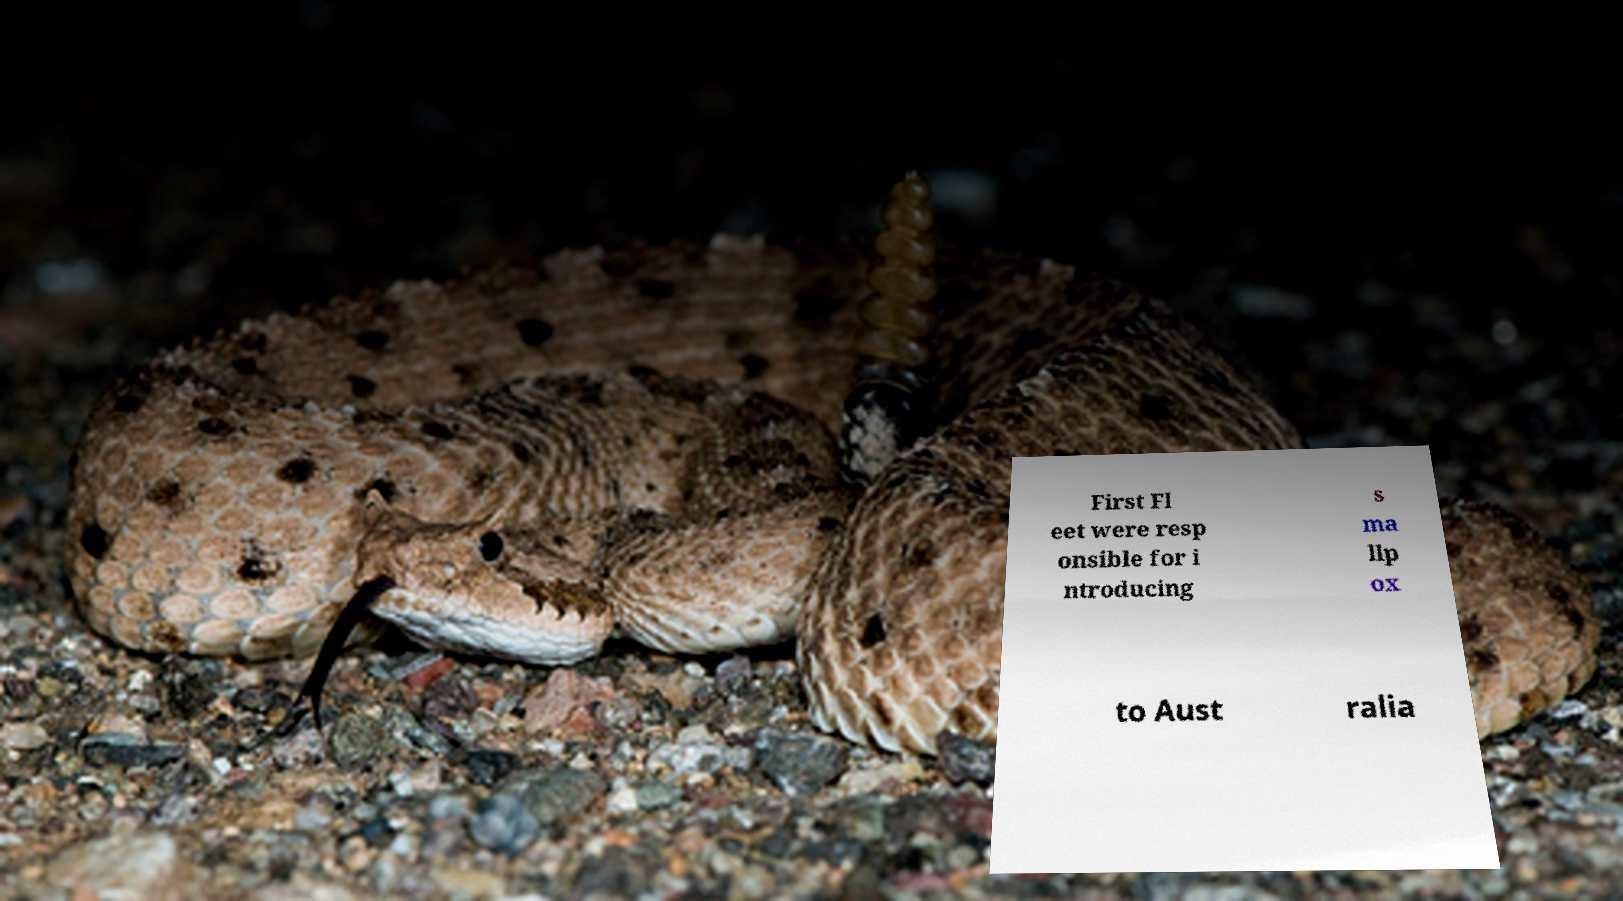There's text embedded in this image that I need extracted. Can you transcribe it verbatim? First Fl eet were resp onsible for i ntroducing s ma llp ox to Aust ralia 